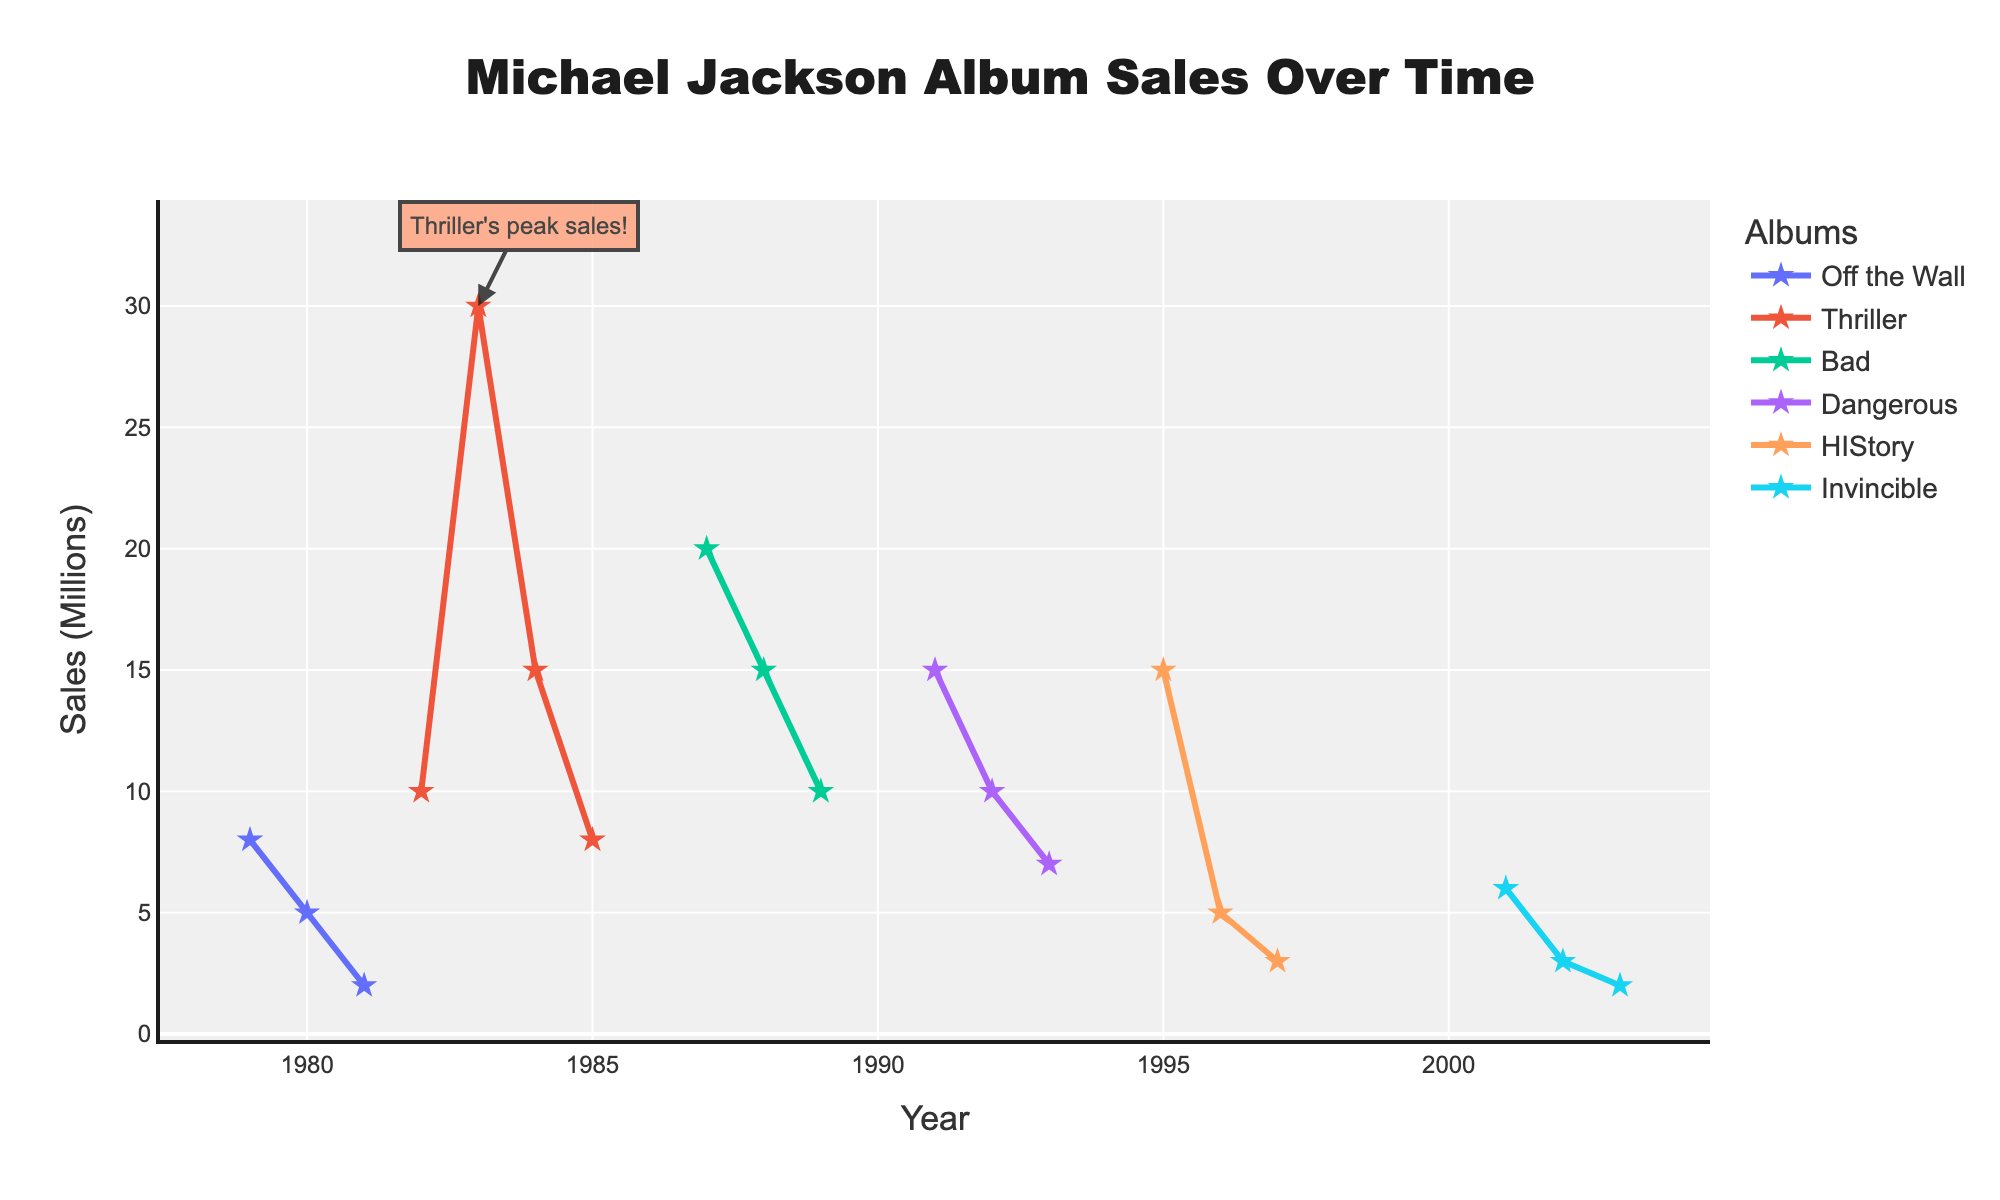What's the title of the plot? The plot's title is located at the top center of the figure. Here, it indicates the theme of the plot regarding sales performance.
Answer: Michael Jackson Album Sales Over Time What's the highest peak sales for any album, and in what year did it occur? The highest peak is annotated in the figure with text stating "Thriller's peak sales!", occurring in the year 1983 with a sales value of 30 million.
Answer: 30 million in 1983 During which years did the 'Off the Wall' album have declining sales? By looking for the 'Off the Wall' trace, its sales were highest in 1979, and declined in subsequent years 1980 and 1981.
Answer: 1980, 1981 Which album's sales declined continuously after its peak year? By observing the line traces, 'HIStory' had its highest sales in 1995 and showed a steady decline in sales through 1996 and 1997.
Answer: HIStory Compare the first three years of sales for 'Bad' and 'Dangerous'. Which album performed better in this period? For 'Bad', the sales in the first three years (1987-1989) were 20, 15, and 10 million, totaling 45 million. For 'Dangerous', the sales from 1991-1993 were 15, 10, and 7 million, totaling 32 million. 'Bad' performed better.
Answer: Bad In what year did the sales for 'Invincible' first drop below 5 million? By tracking the 'Invincible' trace, the sales dropped below 5 million in the year 2002.
Answer: 2002 What was the total sales value for the 'Thriller' album over its recorded period? Summing up the sales for 'Thriller' in 1982 (10), 1983 (30), 1984 (15), and 1985 (8) results in a total of 63 million.
Answer: 63 million Which album had the smallest difference between its highest and lowest sales values? Calculating the differences: 'Off the Wall' (8-2=6), 'Thriller' (30-8=22), 'Bad' (20-10=10), 'Dangerous' (15-7=8), 'HIStory' (15-3=12), and 'Invincible' (6-2=4). 'Invincible' has the smallest difference.
Answer: Invincible Calculate the average sales for the album 'Dangerous' over its three recorded years. The sales for 'Dangerous' in 1991, 1992, and 1993 are 15, 10, and 7 million respectively. The average is (15+10+7)/3 = 10.67 million.
Answer: 10.67 million 